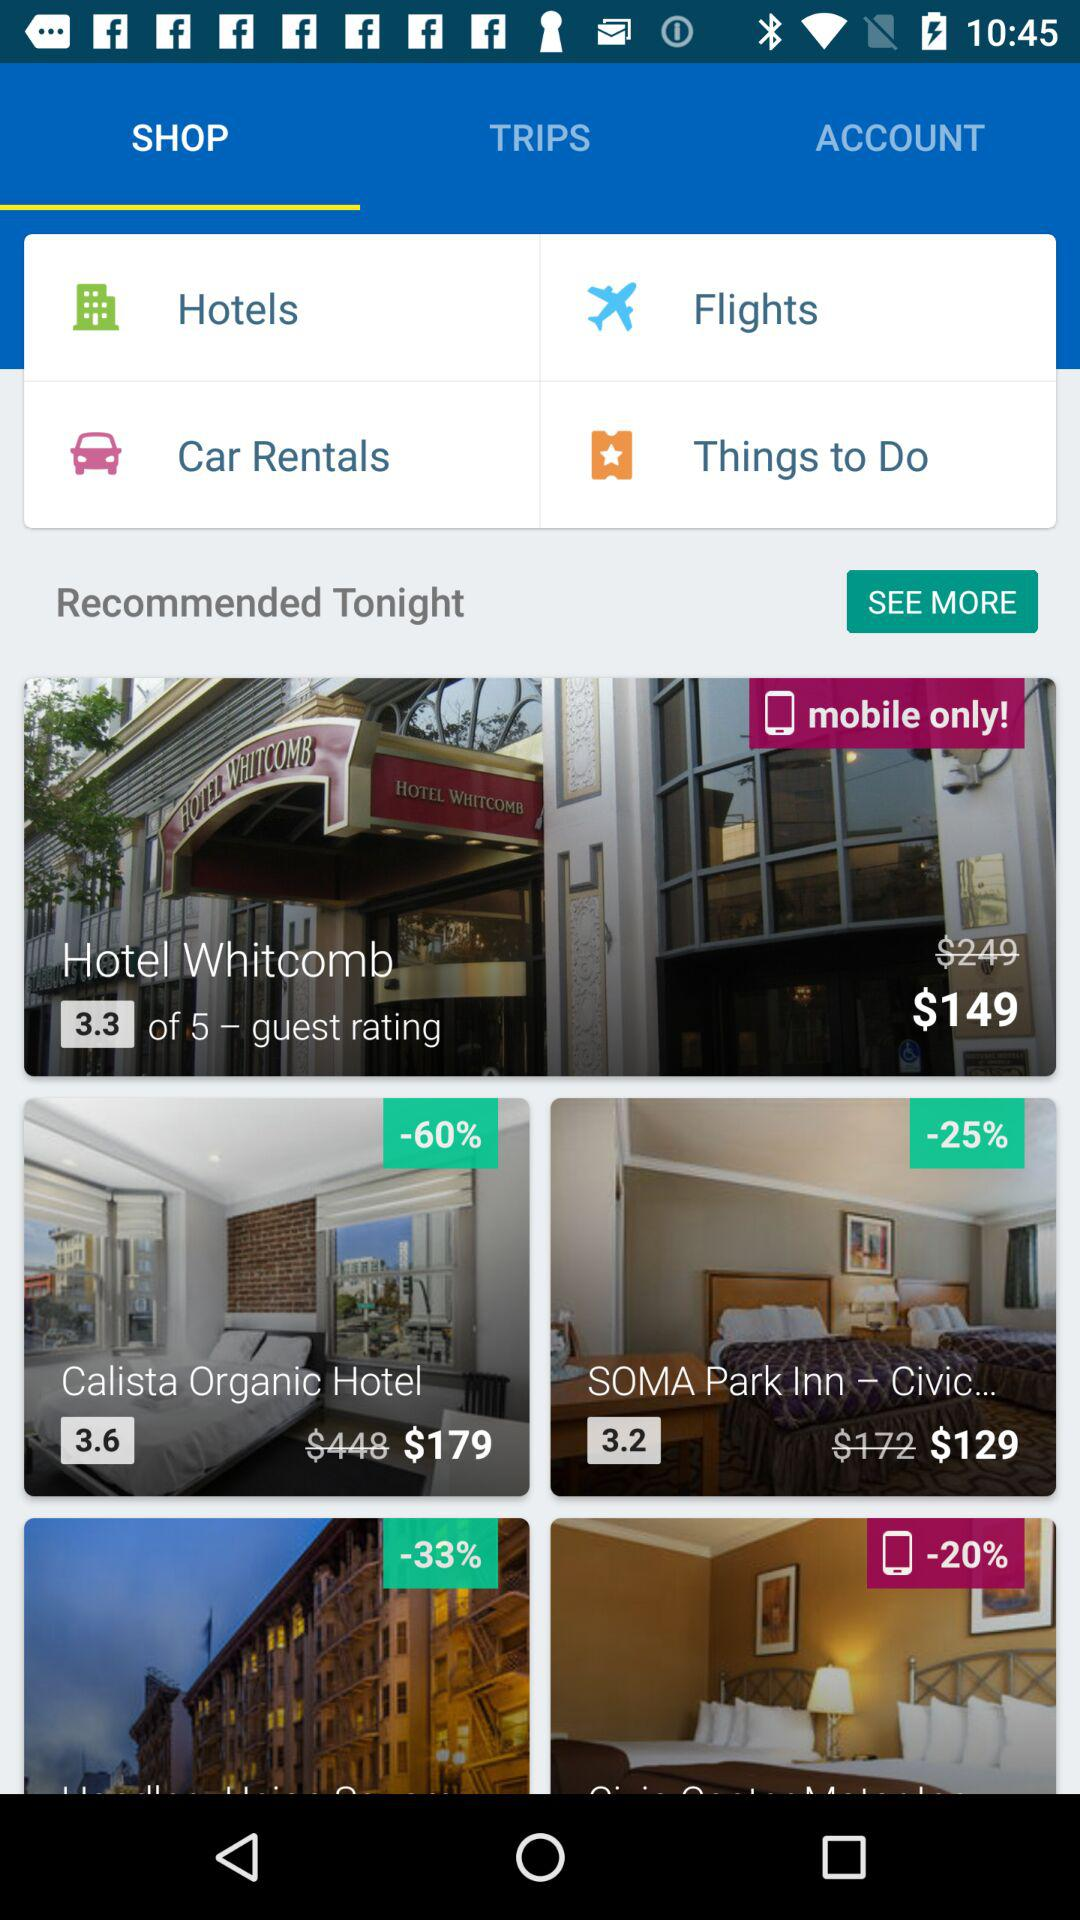How much is the cost of the "Calista Organic Hotel"? The cost is $179. 